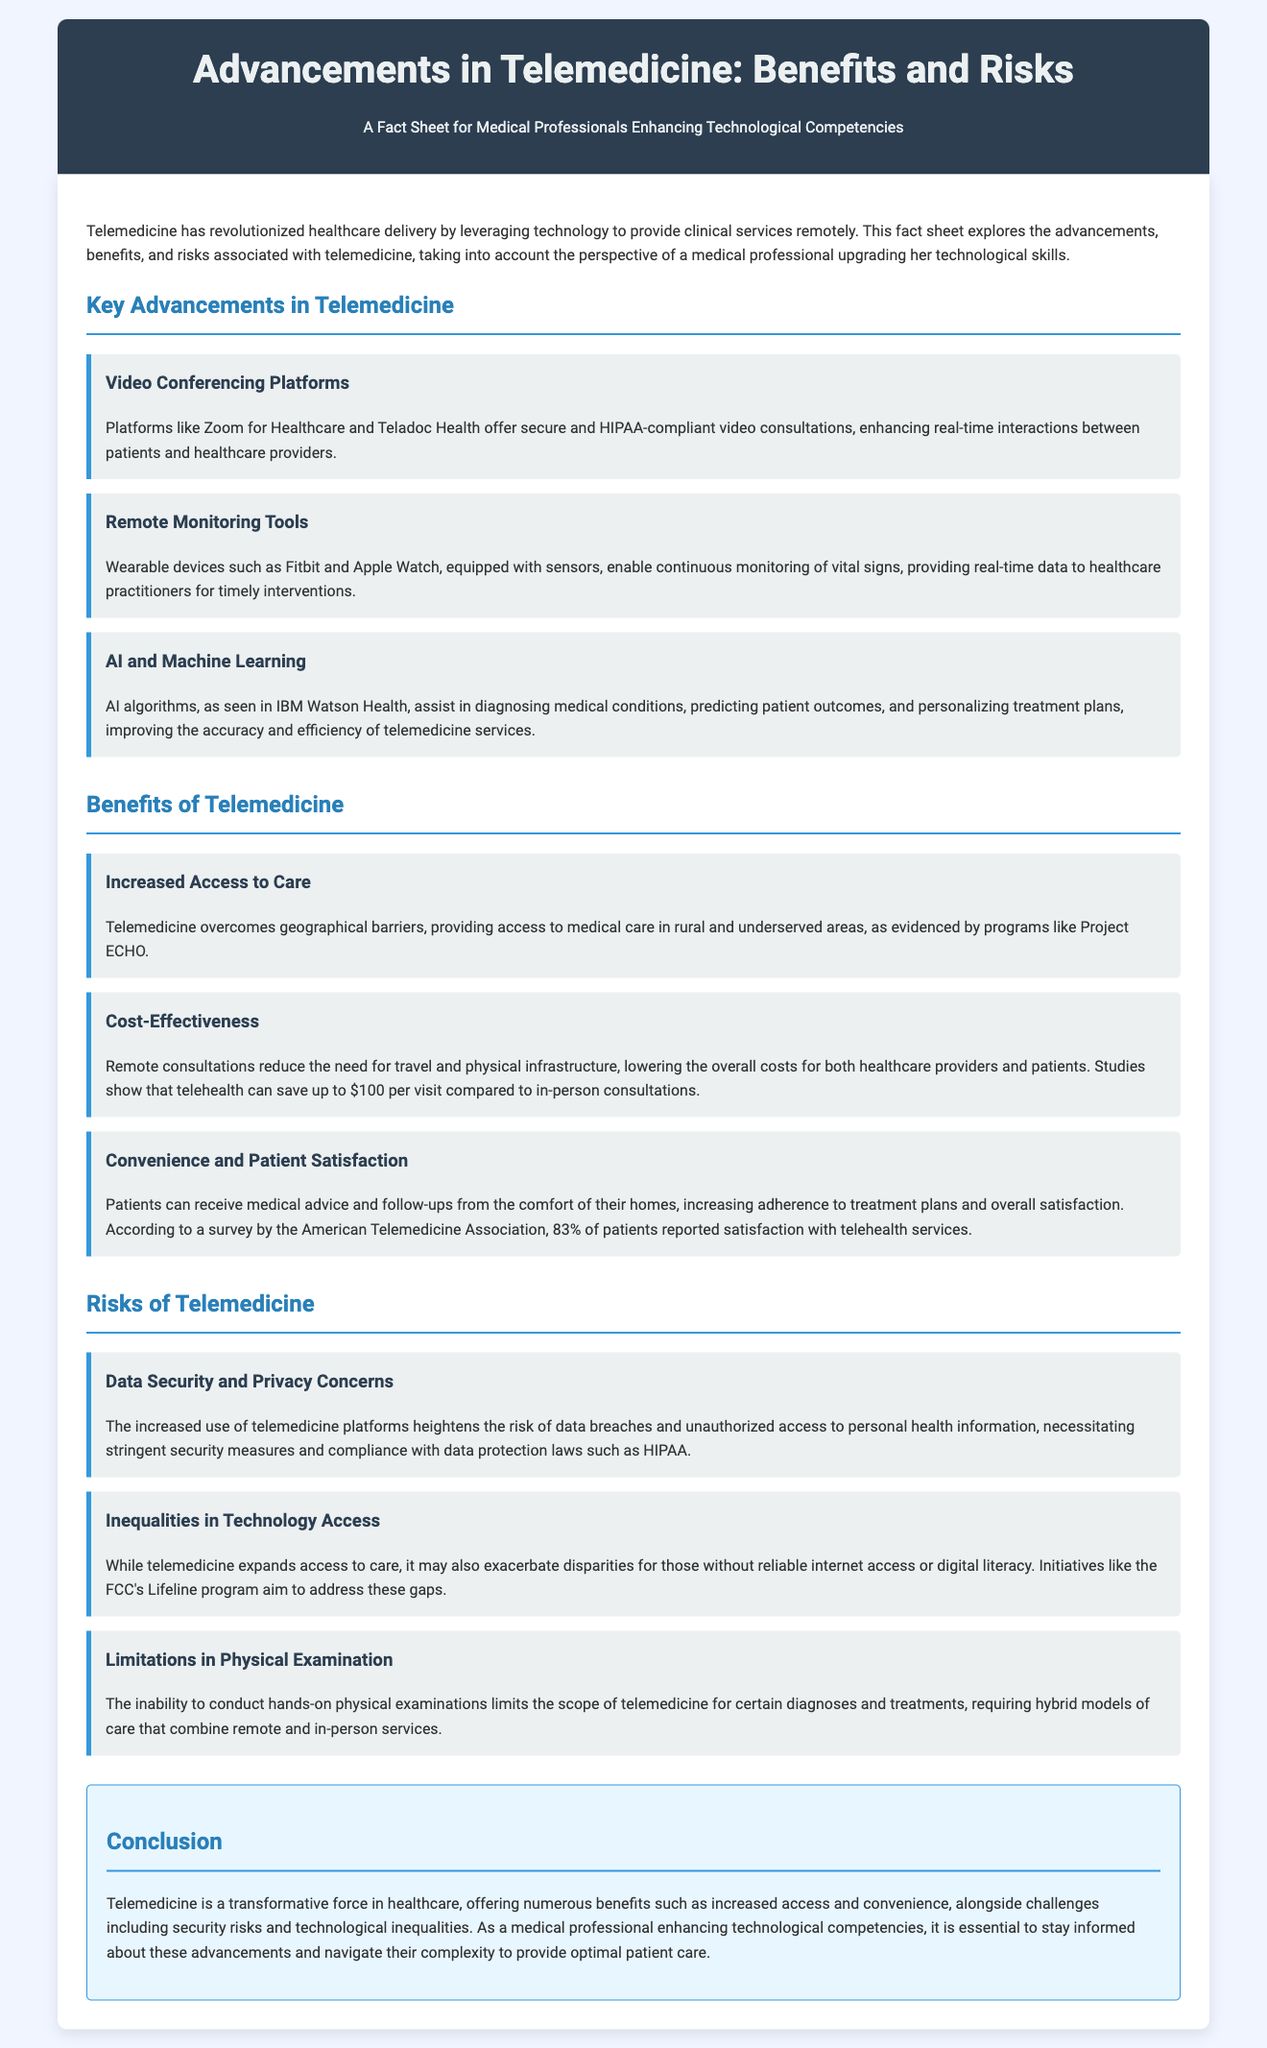What are some key advancements in telemedicine? The document lists advancements such as video conferencing platforms, remote monitoring tools, and AI and machine learning.
Answer: Video conferencing platforms, remote monitoring tools, AI and machine learning What advantage does telemedicine offer in terms of geographical access? Telemedicine helps overcome geographical barriers to medical care, especially in rural and underserved areas.
Answer: Increased access to care How much can telehealth save per visit compared to in-person consultations? The document states that studies show telehealth can save up to $100 per visit.
Answer: $100 What is a major risk associated with the increased use of telemedicine? The document highlights data security and privacy concerns as a significant risk.
Answer: Data security and privacy concerns What is the satisfaction rate reported by patients using telehealth services? According to a survey by the American Telemedicine Association, 83% of patients reported satisfaction with telehealth services.
Answer: 83% How does telemedicine impact those without reliable internet access? The document mentions that telemedicine may exacerbate disparities for individuals lacking reliable internet access or digital literacy.
Answer: Inequalities in technology access What is a limitation of telemedicine regarding medical diagnoses? The document explains that the inability to conduct hands-on examinations limits the scope of telemedicine for certain diagnoses.
Answer: Limitations in physical examination What are the two main themes discussed in the conclusion of the document? The conclusion summarizes benefits and challenges related to telemedicine that professionals should navigate.
Answer: Benefits and challenges 